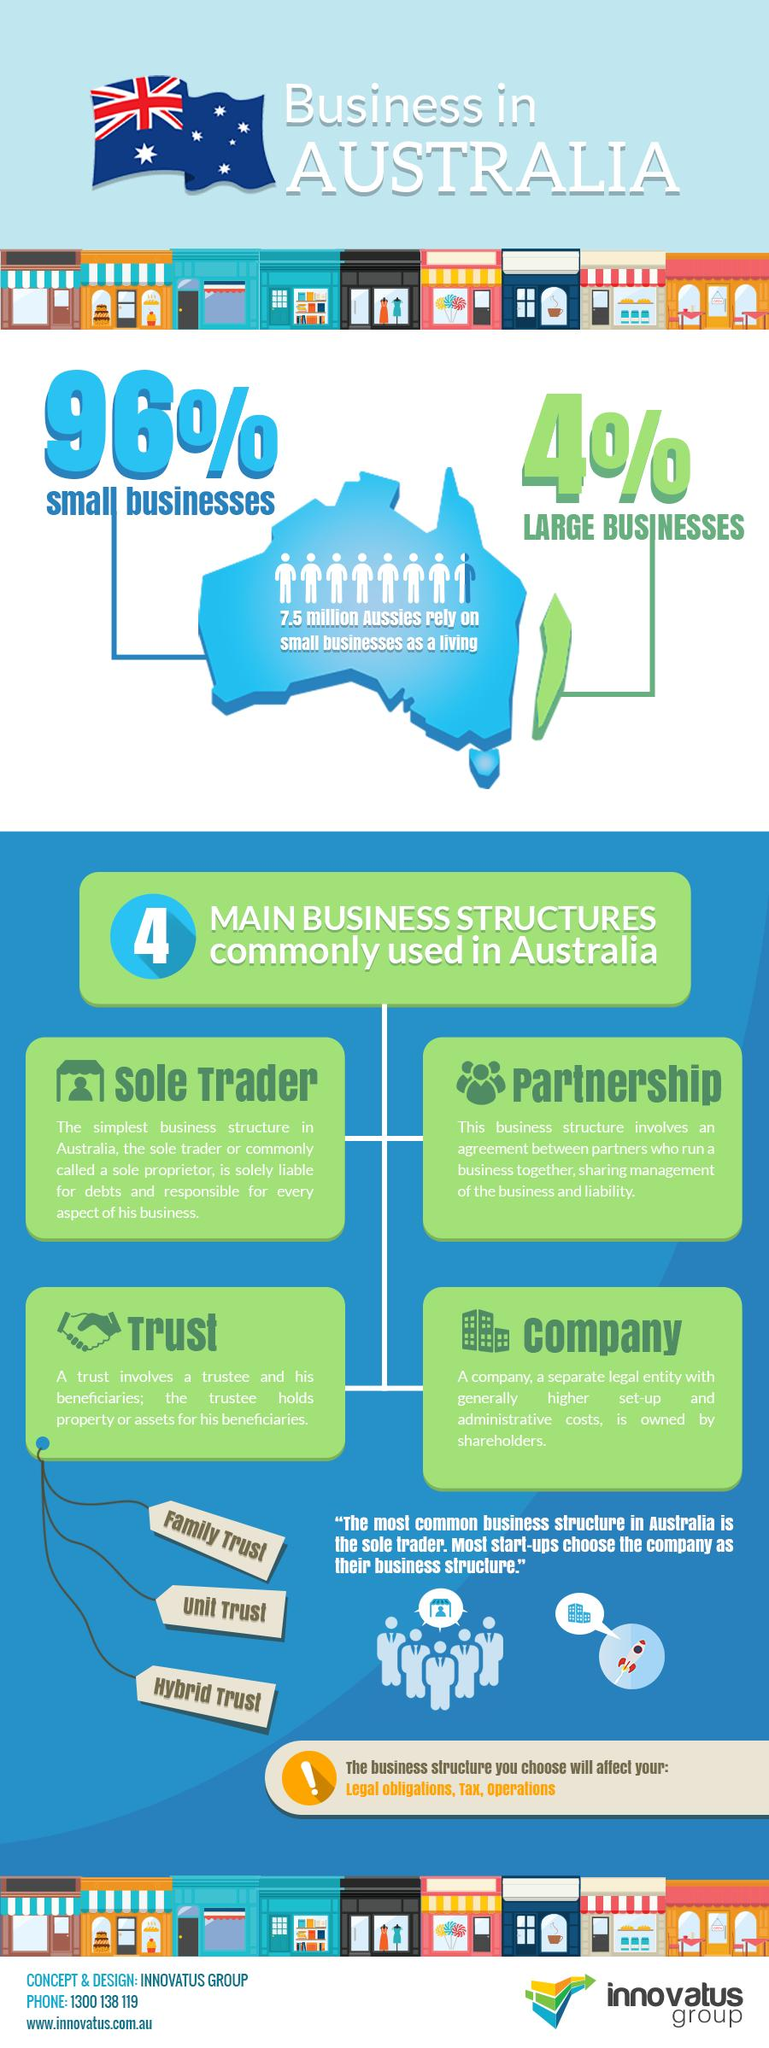Identify some key points in this picture. Small businesses largely dominate the Australian economy, making up the majority of businesses and contributing significantly to the country's economic growth. Four is a commonly used business structure in Australia. In the Australian economy, large businesses tend to dominate and have a significant influence on the market. However, some businesses, particularly small and medium-sized enterprises, struggle to compete with the resources and power of large corporations. Despite this, these smaller businesses play an important role in driving innovation and diversity in the economy. Approximately 7.5 million Australians rely on small businesses for their primary source of income. 